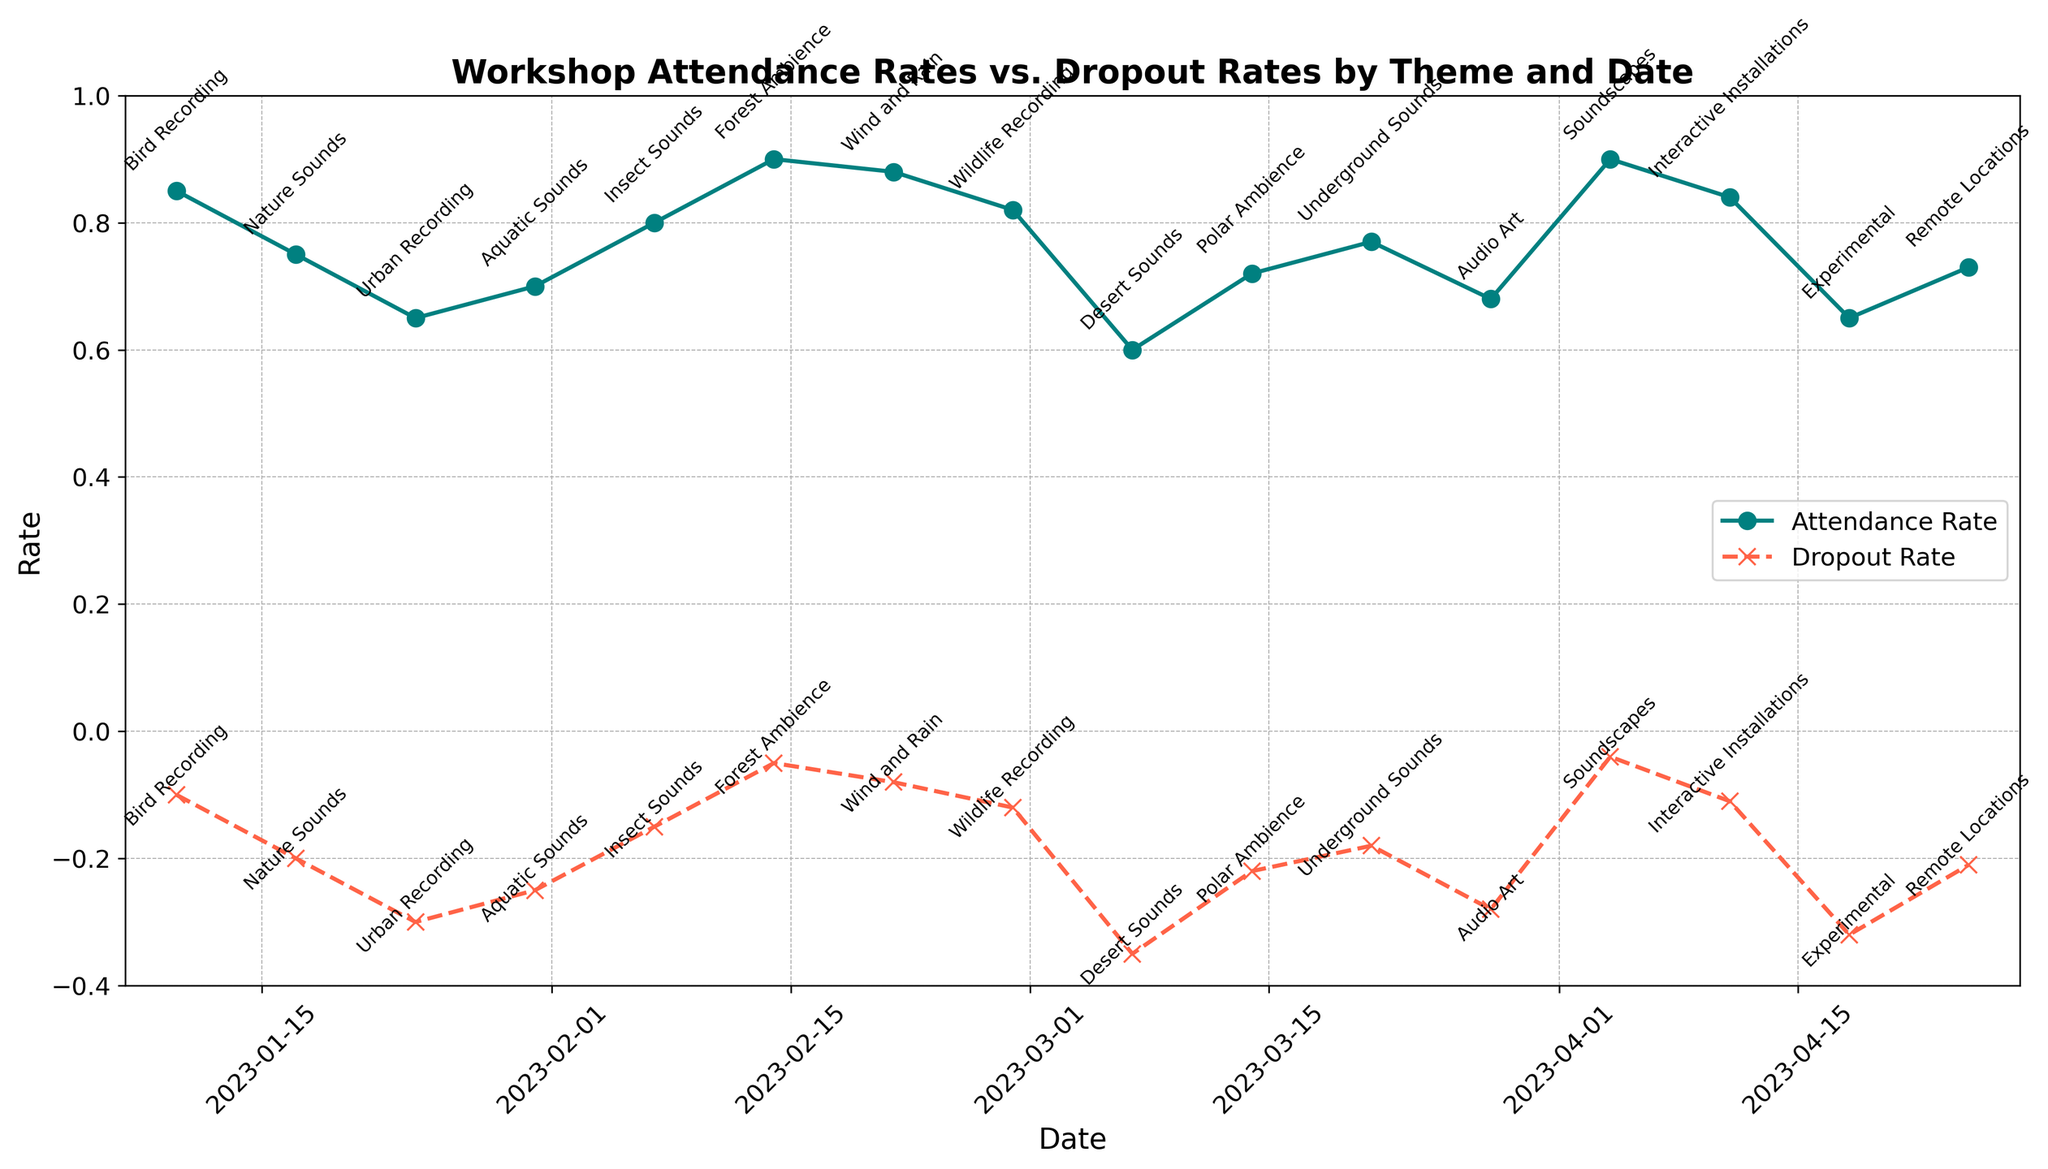What's the theme with the highest attendance rate? The theme with the highest attendance rate can be identified by looking at the highest point on the attendance rate line. By inspecting the plot, we see the peak attendance rate is for "Forest Ambience" with a value of 0.90.
Answer: Forest Ambience Which theme has the lowest dropout rate? The theme with the lowest dropout rate corresponds to the highest point in the dropout rate line (since it's negative). Observing the chart, "Soundscapes" has the lowest dropout rate at -0.04.
Answer: Soundscapes What is the difference in attendance rate between "Bird Recording" and "Desert Sounds"? The attendance rate for "Bird Recording" is 0.85, and for "Desert Sounds" it's 0.60. The difference is calculated by subtracting 0.60 from 0.85.
Answer: 0.25 Which theme has the largest gap between attendance rate and dropout rate? The largest gap can be found by identifying the widest vertical distance between the attendance rate and dropout rate lines for any given theme. Calculating the differences, the largest gap is with "Forest Ambience" (0.90 - (-0.05) = 0.95).
Answer: Forest Ambience Which themes have an attendance rate of 0.80 or higher? By looking at the attendance rate line, the themes with a rate of 0.80 or higher include "Bird Recording" (0.85), "Forest Ambience" (0.90), "Wind and Rain" (0.88), "Wildlife Recording" (0.82), "Soundscapes" (0.90), and "Interactive Installations" (0.84).
Answer: Bird Recording, Forest Ambience, Wind and Rain, Wildlife Recording, Soundscapes, Interactive Installations What’s the average dropout rate for the workshops held in February? The workshops in February are "Forest Ambience", "Wind and Rain", and "Wildlife Recording". Their dropout rates are -0.05, -0.08, and -0.12 respectively. The average dropout rate is calculated as follows: (-0.05 + -0.08 + -0.12) / 3 = -0.0833.
Answer: -0.0833 Which date saw the highest dropout rate and what was it? The highest dropout rate corresponds to the lowest point on the dropout rate line. "Desert Sounds" on 2023-03-07 has the highest dropout rate of -0.35.
Answer: 2023-03-07, -0.35 Compare the attendance rates for "Audio Art" and "Remote Locations". Which one had a higher rate and by how much? The attendance rate for "Audio Art" is 0.68 and for "Remote Locations" it is 0.73. "Remote Locations" had a higher rate. The difference is 0.73 - 0.68 = 0.05.
Answer: Remote Locations, 0.05 What is the median attendance rate across all workshops? To find the median, we arrange the attendance rates in ascending order and find the middle value. The sorted list is [0.60, 0.65, 0.65, 0.68, 0.70, 0.72, 0.73, 0.75, 0.77, 0.80, 0.82, 0.84, 0.85, 0.88, 0.90, 0.90]. With 16 values, the median is the average of the 8th and 9th values: (0.75 + 0.77) / 2 = 0.76.
Answer: 0.76 On which date did the "Urban Recording" workshop occur? By looking at the annotations along the attendance and dropout rate lines, the "Urban Recording" workshop occurred on 2023-01-24.
Answer: 2023-01-24 